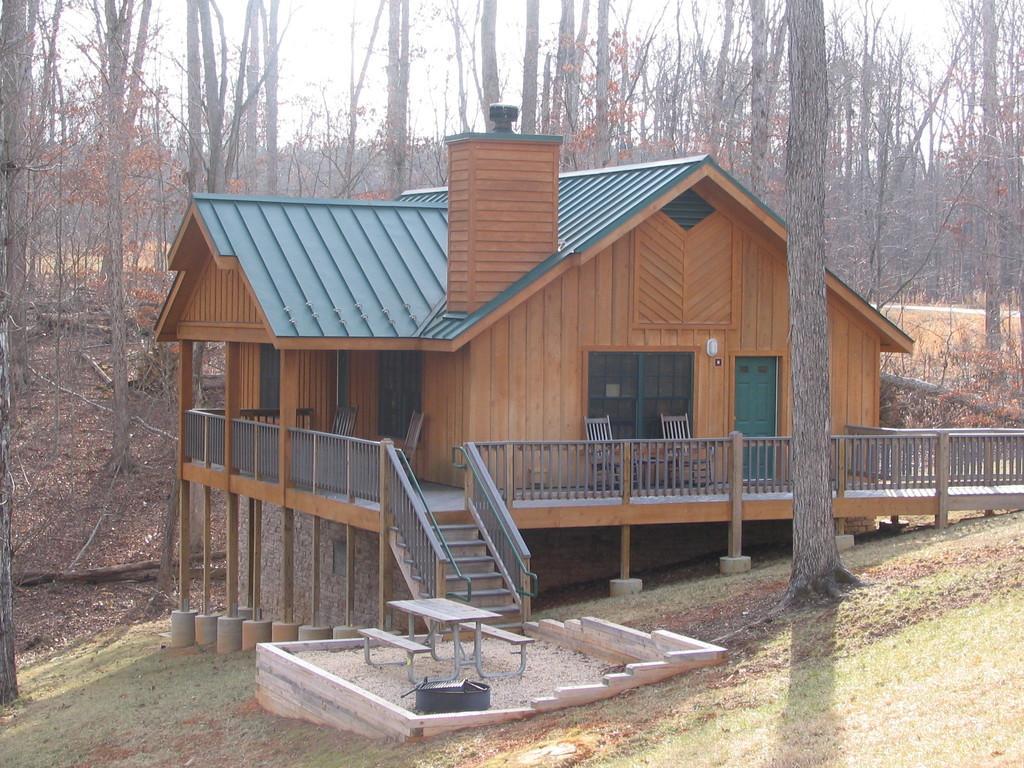How would you summarize this image in a sentence or two? In this image I can see the grass. I can see a table. I can see a house with stairs, doors and windows. I can see the chairs. In the background, I can see the trees. 